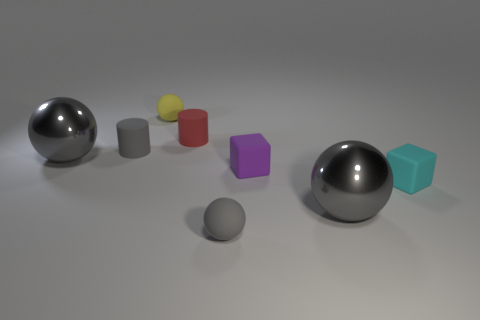Subtract all green cylinders. How many gray balls are left? 3 Add 2 matte things. How many objects exist? 10 Subtract all purple cylinders. Subtract all brown cubes. How many cylinders are left? 2 Subtract all cylinders. How many objects are left? 6 Add 5 tiny blocks. How many tiny blocks exist? 7 Subtract 0 red cubes. How many objects are left? 8 Subtract all tiny cyan cubes. Subtract all small balls. How many objects are left? 5 Add 1 small gray matte balls. How many small gray matte balls are left? 2 